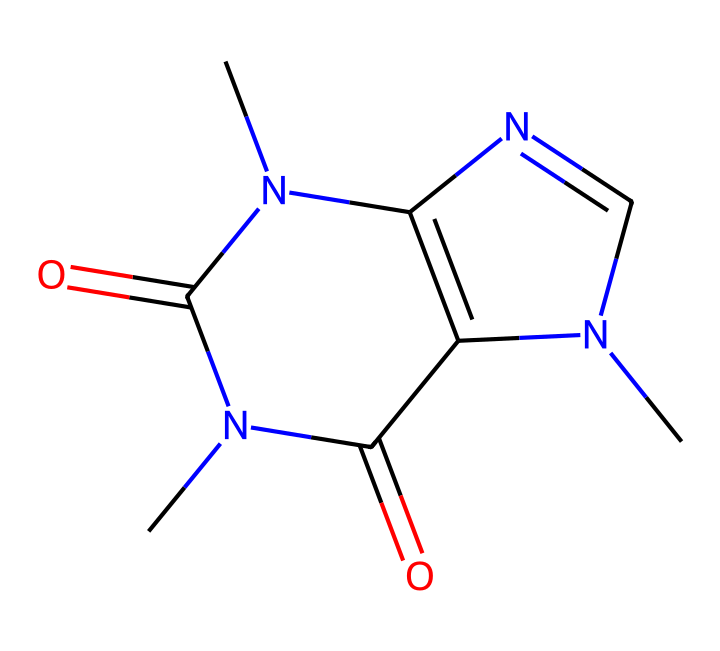What is the molecular formula of caffeine? To find the molecular formula, we can count the types and numbers of atoms in the SMILES representation. Caffeine contains 8 carbon (C), 10 hydrogen (H), and 4 nitrogen (N), leading to the formula C8H10N4O2.
Answer: C8H10N4O2 How many nitrogen atoms are present in the chemical structure? By examining the SMILES, we can identify the position of nitrogen atoms. There are four nitrogen atoms evident in the structure, which are marked by 'N' in the formula.
Answer: 4 Does this chemical contain any oxygen atoms? In the given SMILES, oxygen is indicated by the 'O' symbols. Counting these, we find there are two oxygen atoms in the caffeine structure.
Answer: 2 Is caffeine a solid, liquid, or gas at room temperature? Caffeine is commonly found in solid form at room temperature, which is a characteristic of non-electrolytes and its high molecular complexity.
Answer: solid What type of molecule is caffeine classified as? Considering its molecular structure and the presence of nitrogen atoms, caffeine is classified as an alkaloid. This organic compound category often contains basic nitrogen atoms and has physiological effects.
Answer: alkaloid How many rings are present in the caffeine structure? Analyzing the structure shows that caffeine has a bicyclic structure, which accounts for two interconnected rings that contribute to its complex arrangement.
Answer: 2 Is caffeine soluble in water? Caffeine, being a non-electrolyte with polar properties due to the nitrogen atoms, is soluble in water, allowing it to dissolve easily.
Answer: yes 